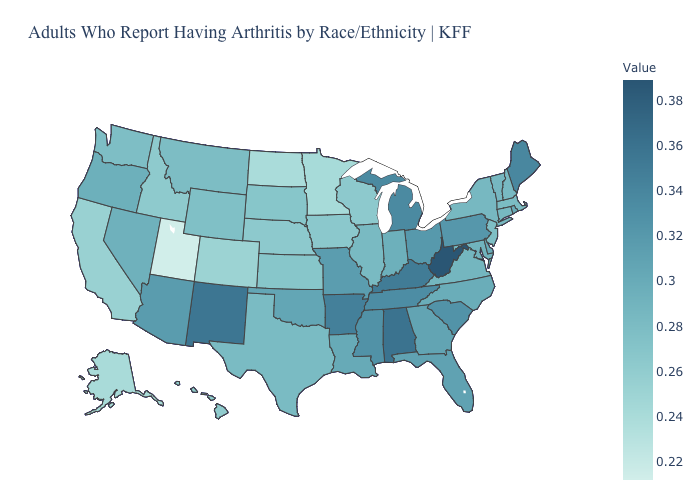Among the states that border Wisconsin , does Illinois have the highest value?
Write a very short answer. No. Does South Dakota have a lower value than Minnesota?
Short answer required. No. Does Kansas have the highest value in the USA?
Keep it brief. No. Does Oklahoma have the highest value in the USA?
Be succinct. No. Which states have the highest value in the USA?
Write a very short answer. West Virginia. Among the states that border Illinois , which have the lowest value?
Quick response, please. Wisconsin. Does the map have missing data?
Short answer required. No. Which states have the lowest value in the West?
Concise answer only. Utah. 